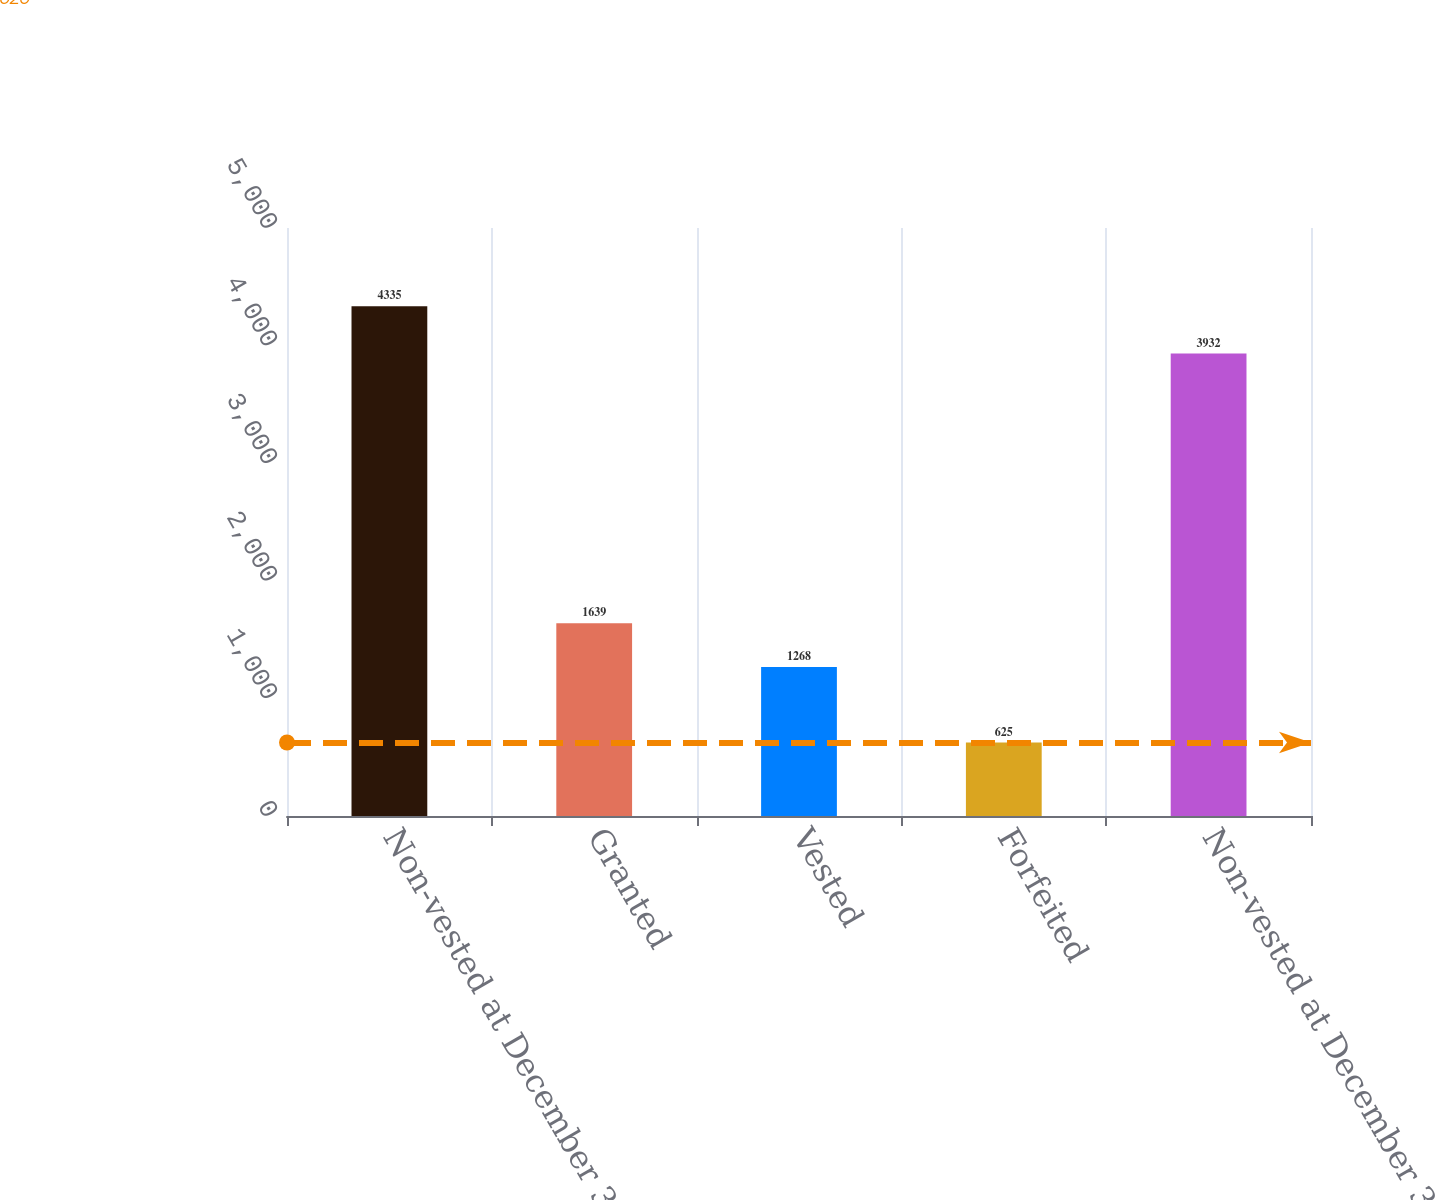Convert chart. <chart><loc_0><loc_0><loc_500><loc_500><bar_chart><fcel>Non-vested at December 31 2007<fcel>Granted<fcel>Vested<fcel>Forfeited<fcel>Non-vested at December 31 2008<nl><fcel>4335<fcel>1639<fcel>1268<fcel>625<fcel>3932<nl></chart> 